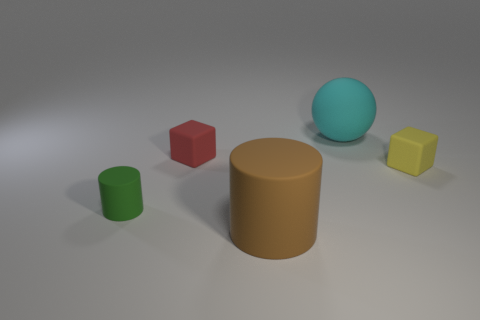How many yellow cubes are the same material as the tiny yellow thing?
Provide a succinct answer. 0. How many spheres are either large cyan matte things or matte objects?
Keep it short and to the point. 1. There is a matte cylinder right of the matte cube on the left side of the matte cylinder right of the tiny cylinder; what is its size?
Your response must be concise. Large. What is the color of the matte thing that is both to the left of the large cylinder and on the right side of the tiny green matte object?
Offer a terse response. Red. There is a brown matte cylinder; is it the same size as the rubber object that is right of the big cyan matte object?
Provide a short and direct response. No. Is there anything else that has the same shape as the tiny yellow object?
Make the answer very short. Yes. What color is the other thing that is the same shape as the yellow object?
Ensure brevity in your answer.  Red. Is the size of the green cylinder the same as the brown matte cylinder?
Provide a short and direct response. No. How many other objects are there of the same size as the cyan sphere?
Ensure brevity in your answer.  1. How many things are either small red objects that are on the left side of the big matte cylinder or things behind the brown matte cylinder?
Ensure brevity in your answer.  4. 